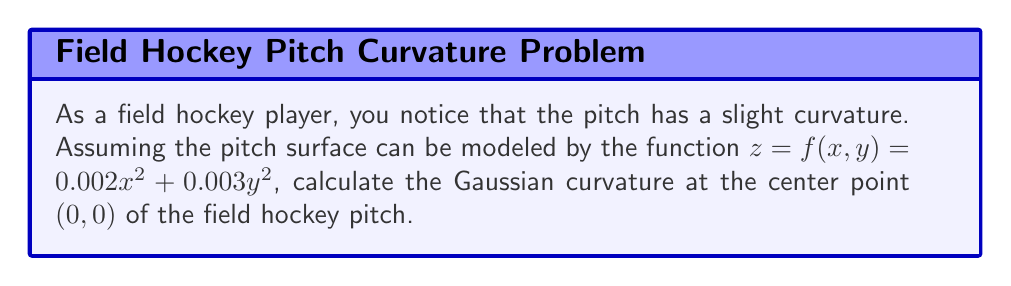Could you help me with this problem? To calculate the Gaussian curvature of the field hockey pitch's terrain, we'll follow these steps:

1) The Gaussian curvature K is given by:

   $$K = \frac{f_{xx}f_{yy} - f_{xy}^2}{(1 + f_x^2 + f_y^2)^2}$$

   where $f_{xx}, f_{yy}, f_{xy}$ are the second partial derivatives, and $f_x, f_y$ are the first partial derivatives.

2) First, let's calculate the partial derivatives:

   $f_x = 0.004x$
   $f_y = 0.006y$
   $f_{xx} = 0.004$
   $f_{yy} = 0.006$
   $f_{xy} = 0$

3) At the center point (0, 0):

   $f_x(0,0) = 0$
   $f_y(0,0) = 0$
   $f_{xx}(0,0) = 0.004$
   $f_{yy}(0,0) = 0.006$
   $f_{xy}(0,0) = 0$

4) Now, let's substitute these values into the Gaussian curvature formula:

   $$K = \frac{(0.004)(0.006) - 0^2}{(1 + 0^2 + 0^2)^2}$$

5) Simplify:

   $$K = \frac{0.000024}{1} = 0.000024$$

Therefore, the Gaussian curvature at the center point (0, 0) of the field hockey pitch is 0.000024.
Answer: $0.000024$ 